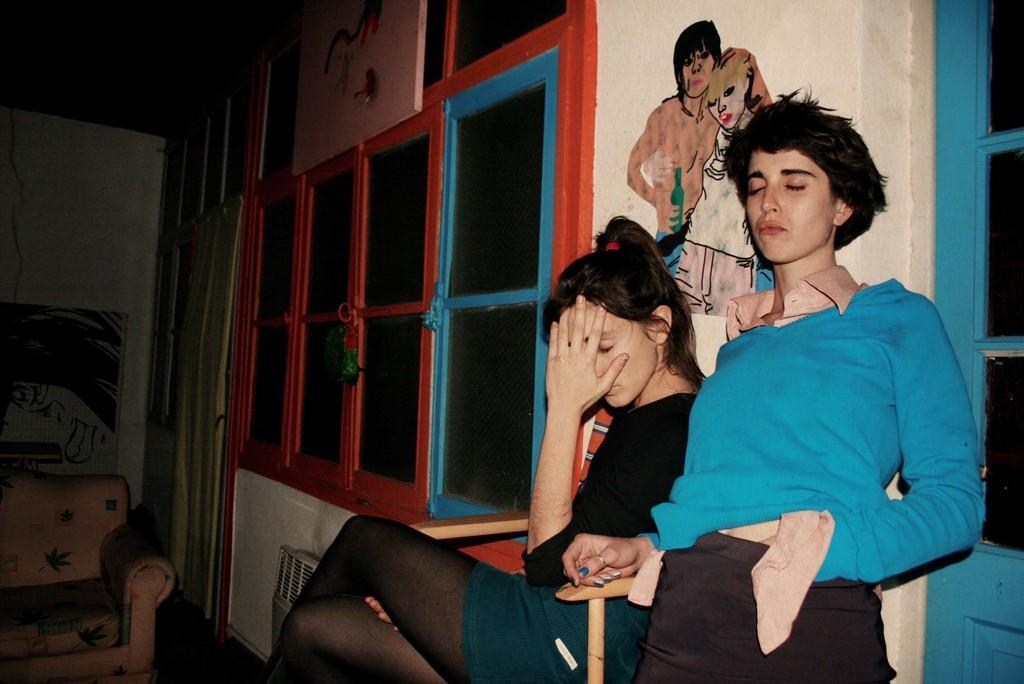How would you summarize this image in a sentence or two? In the image there are two women they are giving different poses, behind the women there is a wall and beside the wall there are many windows, on the left side there is a sofa and in the background there is a white color wall. 